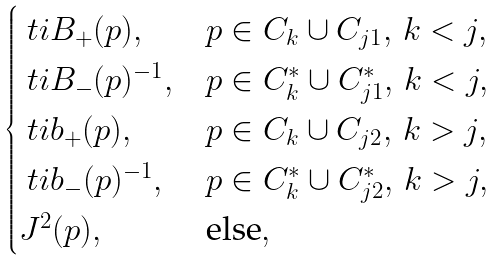Convert formula to latex. <formula><loc_0><loc_0><loc_500><loc_500>\begin{cases} \ t i { B } _ { + } ( p ) , & p \in C _ { k } \cup C _ { j 1 } , \, k < j , \\ \ t i { B } _ { - } ( p ) ^ { - 1 } , & p \in C _ { k } ^ { * } \cup C _ { j 1 } ^ { * } , \, k < j , \\ \ t i { b } _ { + } ( p ) , & p \in C _ { k } \cup C _ { j 2 } , \, k > j , \\ \ t i { b } _ { - } ( p ) ^ { - 1 } , & p \in C _ { k } ^ { * } \cup C _ { j 2 } ^ { * } , \, k > j , \\ J ^ { 2 } ( p ) , & \text {else} , \end{cases}</formula> 